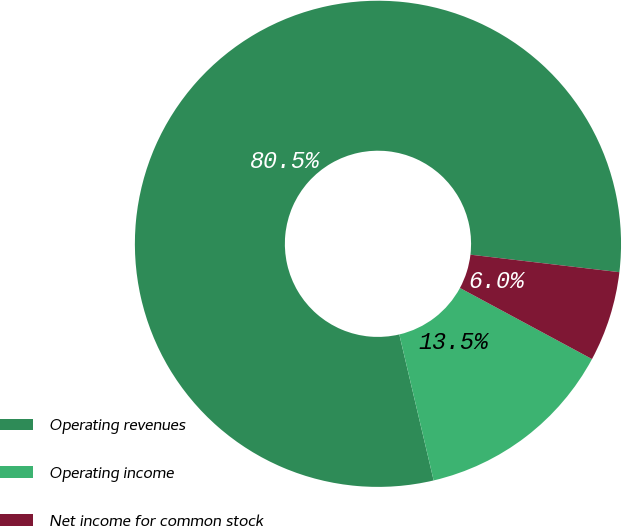Convert chart. <chart><loc_0><loc_0><loc_500><loc_500><pie_chart><fcel>Operating revenues<fcel>Operating income<fcel>Net income for common stock<nl><fcel>80.54%<fcel>13.46%<fcel>6.0%<nl></chart> 